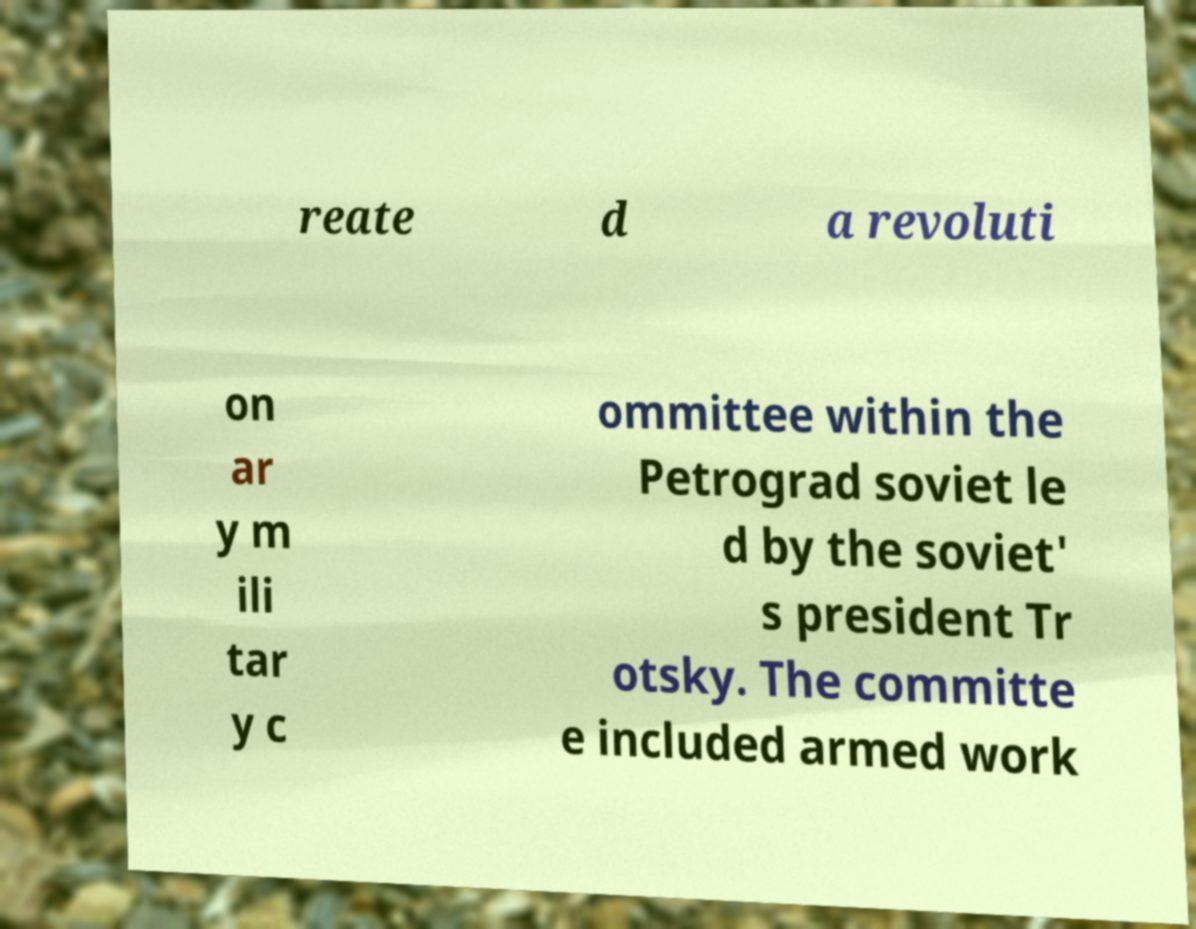There's text embedded in this image that I need extracted. Can you transcribe it verbatim? reate d a revoluti on ar y m ili tar y c ommittee within the Petrograd soviet le d by the soviet' s president Tr otsky. The committe e included armed work 